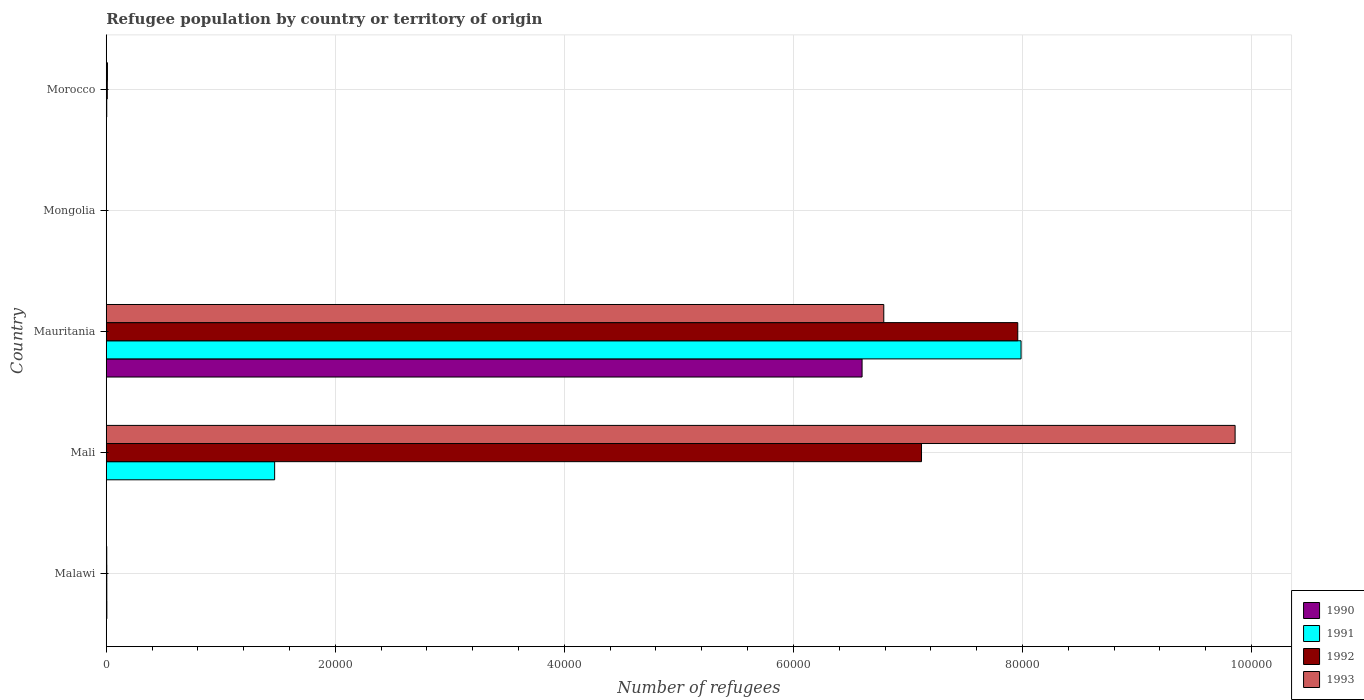How many groups of bars are there?
Offer a terse response. 5. Are the number of bars per tick equal to the number of legend labels?
Provide a short and direct response. Yes. What is the label of the 1st group of bars from the top?
Offer a terse response. Morocco. What is the number of refugees in 1991 in Malawi?
Provide a short and direct response. 50. Across all countries, what is the maximum number of refugees in 1991?
Your answer should be compact. 7.99e+04. In which country was the number of refugees in 1990 maximum?
Provide a succinct answer. Mauritania. In which country was the number of refugees in 1992 minimum?
Ensure brevity in your answer.  Mongolia. What is the total number of refugees in 1992 in the graph?
Offer a very short reply. 1.51e+05. What is the difference between the number of refugees in 1992 in Mauritania and that in Mongolia?
Your answer should be compact. 7.96e+04. What is the difference between the number of refugees in 1993 in Morocco and the number of refugees in 1990 in Mauritania?
Keep it short and to the point. -6.59e+04. What is the average number of refugees in 1992 per country?
Provide a succinct answer. 3.02e+04. What is the difference between the number of refugees in 1990 and number of refugees in 1992 in Malawi?
Provide a succinct answer. 3. What is the ratio of the number of refugees in 1991 in Malawi to that in Mali?
Provide a succinct answer. 0. Is the difference between the number of refugees in 1990 in Mongolia and Morocco greater than the difference between the number of refugees in 1992 in Mongolia and Morocco?
Make the answer very short. Yes. What is the difference between the highest and the second highest number of refugees in 1992?
Ensure brevity in your answer.  8405. What is the difference between the highest and the lowest number of refugees in 1992?
Your answer should be compact. 7.96e+04. Is it the case that in every country, the sum of the number of refugees in 1992 and number of refugees in 1990 is greater than the sum of number of refugees in 1991 and number of refugees in 1993?
Your answer should be very brief. No. What does the 3rd bar from the top in Mauritania represents?
Ensure brevity in your answer.  1991. What does the 3rd bar from the bottom in Morocco represents?
Make the answer very short. 1992. Is it the case that in every country, the sum of the number of refugees in 1990 and number of refugees in 1991 is greater than the number of refugees in 1993?
Offer a terse response. No. Are all the bars in the graph horizontal?
Provide a succinct answer. Yes. Where does the legend appear in the graph?
Offer a very short reply. Bottom right. How many legend labels are there?
Offer a terse response. 4. What is the title of the graph?
Offer a terse response. Refugee population by country or territory of origin. What is the label or title of the X-axis?
Offer a terse response. Number of refugees. What is the Number of refugees of 1990 in Malawi?
Provide a short and direct response. 53. What is the Number of refugees in 1991 in Malawi?
Make the answer very short. 50. What is the Number of refugees in 1992 in Malawi?
Provide a succinct answer. 50. What is the Number of refugees in 1990 in Mali?
Ensure brevity in your answer.  1. What is the Number of refugees in 1991 in Mali?
Offer a terse response. 1.47e+04. What is the Number of refugees in 1992 in Mali?
Provide a succinct answer. 7.12e+04. What is the Number of refugees in 1993 in Mali?
Your response must be concise. 9.86e+04. What is the Number of refugees of 1990 in Mauritania?
Provide a short and direct response. 6.60e+04. What is the Number of refugees in 1991 in Mauritania?
Provide a succinct answer. 7.99e+04. What is the Number of refugees of 1992 in Mauritania?
Provide a short and direct response. 7.96e+04. What is the Number of refugees of 1993 in Mauritania?
Your answer should be compact. 6.79e+04. What is the Number of refugees in 1991 in Mongolia?
Keep it short and to the point. 1. What is the Number of refugees of 1992 in Mongolia?
Offer a very short reply. 1. What is the Number of refugees in 1993 in Mongolia?
Provide a short and direct response. 1. What is the Number of refugees of 1990 in Morocco?
Make the answer very short. 15. What is the Number of refugees in 1991 in Morocco?
Your answer should be compact. 44. What is the Number of refugees of 1992 in Morocco?
Give a very brief answer. 91. What is the Number of refugees in 1993 in Morocco?
Your response must be concise. 105. Across all countries, what is the maximum Number of refugees in 1990?
Offer a very short reply. 6.60e+04. Across all countries, what is the maximum Number of refugees in 1991?
Give a very brief answer. 7.99e+04. Across all countries, what is the maximum Number of refugees in 1992?
Provide a succinct answer. 7.96e+04. Across all countries, what is the maximum Number of refugees of 1993?
Keep it short and to the point. 9.86e+04. Across all countries, what is the minimum Number of refugees of 1991?
Offer a terse response. 1. Across all countries, what is the minimum Number of refugees of 1992?
Give a very brief answer. 1. Across all countries, what is the minimum Number of refugees of 1993?
Provide a short and direct response. 1. What is the total Number of refugees of 1990 in the graph?
Your response must be concise. 6.61e+04. What is the total Number of refugees of 1991 in the graph?
Give a very brief answer. 9.47e+04. What is the total Number of refugees of 1992 in the graph?
Your response must be concise. 1.51e+05. What is the total Number of refugees of 1993 in the graph?
Provide a succinct answer. 1.67e+05. What is the difference between the Number of refugees in 1991 in Malawi and that in Mali?
Provide a succinct answer. -1.47e+04. What is the difference between the Number of refugees in 1992 in Malawi and that in Mali?
Give a very brief answer. -7.11e+04. What is the difference between the Number of refugees of 1993 in Malawi and that in Mali?
Keep it short and to the point. -9.85e+04. What is the difference between the Number of refugees in 1990 in Malawi and that in Mauritania?
Offer a terse response. -6.59e+04. What is the difference between the Number of refugees in 1991 in Malawi and that in Mauritania?
Give a very brief answer. -7.98e+04. What is the difference between the Number of refugees in 1992 in Malawi and that in Mauritania?
Your answer should be very brief. -7.95e+04. What is the difference between the Number of refugees in 1993 in Malawi and that in Mauritania?
Provide a succinct answer. -6.78e+04. What is the difference between the Number of refugees of 1992 in Malawi and that in Mongolia?
Your answer should be compact. 49. What is the difference between the Number of refugees in 1991 in Malawi and that in Morocco?
Ensure brevity in your answer.  6. What is the difference between the Number of refugees of 1992 in Malawi and that in Morocco?
Provide a short and direct response. -41. What is the difference between the Number of refugees in 1993 in Malawi and that in Morocco?
Offer a terse response. -61. What is the difference between the Number of refugees in 1990 in Mali and that in Mauritania?
Ensure brevity in your answer.  -6.60e+04. What is the difference between the Number of refugees of 1991 in Mali and that in Mauritania?
Your answer should be very brief. -6.52e+04. What is the difference between the Number of refugees in 1992 in Mali and that in Mauritania?
Make the answer very short. -8405. What is the difference between the Number of refugees of 1993 in Mali and that in Mauritania?
Provide a short and direct response. 3.07e+04. What is the difference between the Number of refugees in 1990 in Mali and that in Mongolia?
Offer a terse response. 0. What is the difference between the Number of refugees of 1991 in Mali and that in Mongolia?
Offer a very short reply. 1.47e+04. What is the difference between the Number of refugees of 1992 in Mali and that in Mongolia?
Give a very brief answer. 7.12e+04. What is the difference between the Number of refugees in 1993 in Mali and that in Mongolia?
Offer a terse response. 9.86e+04. What is the difference between the Number of refugees of 1990 in Mali and that in Morocco?
Make the answer very short. -14. What is the difference between the Number of refugees in 1991 in Mali and that in Morocco?
Offer a very short reply. 1.47e+04. What is the difference between the Number of refugees in 1992 in Mali and that in Morocco?
Make the answer very short. 7.11e+04. What is the difference between the Number of refugees of 1993 in Mali and that in Morocco?
Ensure brevity in your answer.  9.85e+04. What is the difference between the Number of refugees in 1990 in Mauritania and that in Mongolia?
Provide a succinct answer. 6.60e+04. What is the difference between the Number of refugees of 1991 in Mauritania and that in Mongolia?
Provide a succinct answer. 7.99e+04. What is the difference between the Number of refugees in 1992 in Mauritania and that in Mongolia?
Keep it short and to the point. 7.96e+04. What is the difference between the Number of refugees of 1993 in Mauritania and that in Mongolia?
Provide a short and direct response. 6.79e+04. What is the difference between the Number of refugees in 1990 in Mauritania and that in Morocco?
Make the answer very short. 6.60e+04. What is the difference between the Number of refugees of 1991 in Mauritania and that in Morocco?
Make the answer very short. 7.98e+04. What is the difference between the Number of refugees in 1992 in Mauritania and that in Morocco?
Your answer should be compact. 7.95e+04. What is the difference between the Number of refugees in 1993 in Mauritania and that in Morocco?
Your answer should be very brief. 6.78e+04. What is the difference between the Number of refugees in 1991 in Mongolia and that in Morocco?
Your response must be concise. -43. What is the difference between the Number of refugees in 1992 in Mongolia and that in Morocco?
Provide a succinct answer. -90. What is the difference between the Number of refugees of 1993 in Mongolia and that in Morocco?
Offer a very short reply. -104. What is the difference between the Number of refugees in 1990 in Malawi and the Number of refugees in 1991 in Mali?
Provide a short and direct response. -1.47e+04. What is the difference between the Number of refugees of 1990 in Malawi and the Number of refugees of 1992 in Mali?
Make the answer very short. -7.11e+04. What is the difference between the Number of refugees of 1990 in Malawi and the Number of refugees of 1993 in Mali?
Make the answer very short. -9.85e+04. What is the difference between the Number of refugees of 1991 in Malawi and the Number of refugees of 1992 in Mali?
Make the answer very short. -7.11e+04. What is the difference between the Number of refugees of 1991 in Malawi and the Number of refugees of 1993 in Mali?
Your answer should be very brief. -9.85e+04. What is the difference between the Number of refugees in 1992 in Malawi and the Number of refugees in 1993 in Mali?
Provide a short and direct response. -9.85e+04. What is the difference between the Number of refugees in 1990 in Malawi and the Number of refugees in 1991 in Mauritania?
Provide a succinct answer. -7.98e+04. What is the difference between the Number of refugees of 1990 in Malawi and the Number of refugees of 1992 in Mauritania?
Provide a succinct answer. -7.95e+04. What is the difference between the Number of refugees in 1990 in Malawi and the Number of refugees in 1993 in Mauritania?
Keep it short and to the point. -6.78e+04. What is the difference between the Number of refugees of 1991 in Malawi and the Number of refugees of 1992 in Mauritania?
Provide a succinct answer. -7.95e+04. What is the difference between the Number of refugees of 1991 in Malawi and the Number of refugees of 1993 in Mauritania?
Keep it short and to the point. -6.78e+04. What is the difference between the Number of refugees of 1992 in Malawi and the Number of refugees of 1993 in Mauritania?
Make the answer very short. -6.78e+04. What is the difference between the Number of refugees of 1990 in Malawi and the Number of refugees of 1992 in Mongolia?
Give a very brief answer. 52. What is the difference between the Number of refugees in 1992 in Malawi and the Number of refugees in 1993 in Mongolia?
Provide a succinct answer. 49. What is the difference between the Number of refugees of 1990 in Malawi and the Number of refugees of 1992 in Morocco?
Give a very brief answer. -38. What is the difference between the Number of refugees in 1990 in Malawi and the Number of refugees in 1993 in Morocco?
Give a very brief answer. -52. What is the difference between the Number of refugees of 1991 in Malawi and the Number of refugees of 1992 in Morocco?
Provide a short and direct response. -41. What is the difference between the Number of refugees in 1991 in Malawi and the Number of refugees in 1993 in Morocco?
Your answer should be compact. -55. What is the difference between the Number of refugees of 1992 in Malawi and the Number of refugees of 1993 in Morocco?
Offer a terse response. -55. What is the difference between the Number of refugees in 1990 in Mali and the Number of refugees in 1991 in Mauritania?
Provide a succinct answer. -7.99e+04. What is the difference between the Number of refugees of 1990 in Mali and the Number of refugees of 1992 in Mauritania?
Offer a terse response. -7.96e+04. What is the difference between the Number of refugees in 1990 in Mali and the Number of refugees in 1993 in Mauritania?
Keep it short and to the point. -6.79e+04. What is the difference between the Number of refugees in 1991 in Mali and the Number of refugees in 1992 in Mauritania?
Keep it short and to the point. -6.49e+04. What is the difference between the Number of refugees in 1991 in Mali and the Number of refugees in 1993 in Mauritania?
Offer a terse response. -5.32e+04. What is the difference between the Number of refugees of 1992 in Mali and the Number of refugees of 1993 in Mauritania?
Your response must be concise. 3295. What is the difference between the Number of refugees of 1990 in Mali and the Number of refugees of 1991 in Mongolia?
Give a very brief answer. 0. What is the difference between the Number of refugees in 1990 in Mali and the Number of refugees in 1993 in Mongolia?
Offer a very short reply. 0. What is the difference between the Number of refugees of 1991 in Mali and the Number of refugees of 1992 in Mongolia?
Offer a terse response. 1.47e+04. What is the difference between the Number of refugees in 1991 in Mali and the Number of refugees in 1993 in Mongolia?
Provide a short and direct response. 1.47e+04. What is the difference between the Number of refugees in 1992 in Mali and the Number of refugees in 1993 in Mongolia?
Your answer should be compact. 7.12e+04. What is the difference between the Number of refugees in 1990 in Mali and the Number of refugees in 1991 in Morocco?
Make the answer very short. -43. What is the difference between the Number of refugees in 1990 in Mali and the Number of refugees in 1992 in Morocco?
Provide a short and direct response. -90. What is the difference between the Number of refugees in 1990 in Mali and the Number of refugees in 1993 in Morocco?
Make the answer very short. -104. What is the difference between the Number of refugees in 1991 in Mali and the Number of refugees in 1992 in Morocco?
Keep it short and to the point. 1.46e+04. What is the difference between the Number of refugees of 1991 in Mali and the Number of refugees of 1993 in Morocco?
Keep it short and to the point. 1.46e+04. What is the difference between the Number of refugees in 1992 in Mali and the Number of refugees in 1993 in Morocco?
Offer a terse response. 7.11e+04. What is the difference between the Number of refugees in 1990 in Mauritania and the Number of refugees in 1991 in Mongolia?
Offer a very short reply. 6.60e+04. What is the difference between the Number of refugees of 1990 in Mauritania and the Number of refugees of 1992 in Mongolia?
Offer a terse response. 6.60e+04. What is the difference between the Number of refugees of 1990 in Mauritania and the Number of refugees of 1993 in Mongolia?
Give a very brief answer. 6.60e+04. What is the difference between the Number of refugees of 1991 in Mauritania and the Number of refugees of 1992 in Mongolia?
Make the answer very short. 7.99e+04. What is the difference between the Number of refugees of 1991 in Mauritania and the Number of refugees of 1993 in Mongolia?
Provide a short and direct response. 7.99e+04. What is the difference between the Number of refugees in 1992 in Mauritania and the Number of refugees in 1993 in Mongolia?
Keep it short and to the point. 7.96e+04. What is the difference between the Number of refugees of 1990 in Mauritania and the Number of refugees of 1991 in Morocco?
Your response must be concise. 6.60e+04. What is the difference between the Number of refugees in 1990 in Mauritania and the Number of refugees in 1992 in Morocco?
Provide a succinct answer. 6.59e+04. What is the difference between the Number of refugees in 1990 in Mauritania and the Number of refugees in 1993 in Morocco?
Your response must be concise. 6.59e+04. What is the difference between the Number of refugees in 1991 in Mauritania and the Number of refugees in 1992 in Morocco?
Provide a short and direct response. 7.98e+04. What is the difference between the Number of refugees of 1991 in Mauritania and the Number of refugees of 1993 in Morocco?
Keep it short and to the point. 7.98e+04. What is the difference between the Number of refugees of 1992 in Mauritania and the Number of refugees of 1993 in Morocco?
Provide a succinct answer. 7.95e+04. What is the difference between the Number of refugees in 1990 in Mongolia and the Number of refugees in 1991 in Morocco?
Keep it short and to the point. -43. What is the difference between the Number of refugees of 1990 in Mongolia and the Number of refugees of 1992 in Morocco?
Offer a terse response. -90. What is the difference between the Number of refugees in 1990 in Mongolia and the Number of refugees in 1993 in Morocco?
Your answer should be compact. -104. What is the difference between the Number of refugees in 1991 in Mongolia and the Number of refugees in 1992 in Morocco?
Give a very brief answer. -90. What is the difference between the Number of refugees in 1991 in Mongolia and the Number of refugees in 1993 in Morocco?
Make the answer very short. -104. What is the difference between the Number of refugees in 1992 in Mongolia and the Number of refugees in 1993 in Morocco?
Offer a terse response. -104. What is the average Number of refugees in 1990 per country?
Offer a very short reply. 1.32e+04. What is the average Number of refugees in 1991 per country?
Provide a succinct answer. 1.89e+04. What is the average Number of refugees in 1992 per country?
Keep it short and to the point. 3.02e+04. What is the average Number of refugees in 1993 per country?
Keep it short and to the point. 3.33e+04. What is the difference between the Number of refugees in 1990 and Number of refugees in 1992 in Malawi?
Offer a very short reply. 3. What is the difference between the Number of refugees of 1990 and Number of refugees of 1993 in Malawi?
Give a very brief answer. 9. What is the difference between the Number of refugees of 1991 and Number of refugees of 1993 in Malawi?
Your answer should be compact. 6. What is the difference between the Number of refugees of 1990 and Number of refugees of 1991 in Mali?
Your response must be concise. -1.47e+04. What is the difference between the Number of refugees of 1990 and Number of refugees of 1992 in Mali?
Provide a succinct answer. -7.12e+04. What is the difference between the Number of refugees in 1990 and Number of refugees in 1993 in Mali?
Keep it short and to the point. -9.86e+04. What is the difference between the Number of refugees of 1991 and Number of refugees of 1992 in Mali?
Give a very brief answer. -5.65e+04. What is the difference between the Number of refugees in 1991 and Number of refugees in 1993 in Mali?
Provide a succinct answer. -8.39e+04. What is the difference between the Number of refugees in 1992 and Number of refugees in 1993 in Mali?
Your answer should be compact. -2.74e+04. What is the difference between the Number of refugees in 1990 and Number of refugees in 1991 in Mauritania?
Ensure brevity in your answer.  -1.39e+04. What is the difference between the Number of refugees in 1990 and Number of refugees in 1992 in Mauritania?
Ensure brevity in your answer.  -1.36e+04. What is the difference between the Number of refugees in 1990 and Number of refugees in 1993 in Mauritania?
Provide a short and direct response. -1895. What is the difference between the Number of refugees in 1991 and Number of refugees in 1992 in Mauritania?
Your answer should be compact. 287. What is the difference between the Number of refugees of 1991 and Number of refugees of 1993 in Mauritania?
Offer a terse response. 1.20e+04. What is the difference between the Number of refugees in 1992 and Number of refugees in 1993 in Mauritania?
Offer a terse response. 1.17e+04. What is the difference between the Number of refugees of 1990 and Number of refugees of 1991 in Morocco?
Your answer should be compact. -29. What is the difference between the Number of refugees in 1990 and Number of refugees in 1992 in Morocco?
Offer a very short reply. -76. What is the difference between the Number of refugees of 1990 and Number of refugees of 1993 in Morocco?
Your answer should be very brief. -90. What is the difference between the Number of refugees in 1991 and Number of refugees in 1992 in Morocco?
Offer a terse response. -47. What is the difference between the Number of refugees in 1991 and Number of refugees in 1993 in Morocco?
Ensure brevity in your answer.  -61. What is the ratio of the Number of refugees of 1990 in Malawi to that in Mali?
Offer a very short reply. 53. What is the ratio of the Number of refugees in 1991 in Malawi to that in Mali?
Provide a short and direct response. 0. What is the ratio of the Number of refugees in 1992 in Malawi to that in Mali?
Provide a short and direct response. 0. What is the ratio of the Number of refugees of 1990 in Malawi to that in Mauritania?
Ensure brevity in your answer.  0. What is the ratio of the Number of refugees of 1991 in Malawi to that in Mauritania?
Give a very brief answer. 0. What is the ratio of the Number of refugees in 1992 in Malawi to that in Mauritania?
Ensure brevity in your answer.  0. What is the ratio of the Number of refugees in 1993 in Malawi to that in Mauritania?
Offer a terse response. 0. What is the ratio of the Number of refugees of 1991 in Malawi to that in Mongolia?
Your response must be concise. 50. What is the ratio of the Number of refugees in 1992 in Malawi to that in Mongolia?
Ensure brevity in your answer.  50. What is the ratio of the Number of refugees in 1993 in Malawi to that in Mongolia?
Your response must be concise. 44. What is the ratio of the Number of refugees of 1990 in Malawi to that in Morocco?
Offer a terse response. 3.53. What is the ratio of the Number of refugees in 1991 in Malawi to that in Morocco?
Offer a terse response. 1.14. What is the ratio of the Number of refugees in 1992 in Malawi to that in Morocco?
Give a very brief answer. 0.55. What is the ratio of the Number of refugees in 1993 in Malawi to that in Morocco?
Your answer should be very brief. 0.42. What is the ratio of the Number of refugees of 1990 in Mali to that in Mauritania?
Ensure brevity in your answer.  0. What is the ratio of the Number of refugees in 1991 in Mali to that in Mauritania?
Ensure brevity in your answer.  0.18. What is the ratio of the Number of refugees of 1992 in Mali to that in Mauritania?
Your answer should be very brief. 0.89. What is the ratio of the Number of refugees in 1993 in Mali to that in Mauritania?
Keep it short and to the point. 1.45. What is the ratio of the Number of refugees of 1990 in Mali to that in Mongolia?
Your answer should be compact. 1. What is the ratio of the Number of refugees of 1991 in Mali to that in Mongolia?
Your answer should be very brief. 1.47e+04. What is the ratio of the Number of refugees of 1992 in Mali to that in Mongolia?
Your answer should be compact. 7.12e+04. What is the ratio of the Number of refugees of 1993 in Mali to that in Mongolia?
Make the answer very short. 9.86e+04. What is the ratio of the Number of refugees in 1990 in Mali to that in Morocco?
Your response must be concise. 0.07. What is the ratio of the Number of refugees of 1991 in Mali to that in Morocco?
Your response must be concise. 334.18. What is the ratio of the Number of refugees of 1992 in Mali to that in Morocco?
Make the answer very short. 782.3. What is the ratio of the Number of refugees in 1993 in Mali to that in Morocco?
Your answer should be very brief. 938.78. What is the ratio of the Number of refugees in 1990 in Mauritania to that in Mongolia?
Offer a very short reply. 6.60e+04. What is the ratio of the Number of refugees of 1991 in Mauritania to that in Mongolia?
Keep it short and to the point. 7.99e+04. What is the ratio of the Number of refugees of 1992 in Mauritania to that in Mongolia?
Your answer should be very brief. 7.96e+04. What is the ratio of the Number of refugees in 1993 in Mauritania to that in Mongolia?
Keep it short and to the point. 6.79e+04. What is the ratio of the Number of refugees in 1990 in Mauritania to that in Morocco?
Your answer should be compact. 4399.93. What is the ratio of the Number of refugees in 1991 in Mauritania to that in Morocco?
Your answer should be very brief. 1815.48. What is the ratio of the Number of refugees in 1992 in Mauritania to that in Morocco?
Offer a terse response. 874.66. What is the ratio of the Number of refugees in 1993 in Mauritania to that in Morocco?
Your response must be concise. 646.61. What is the ratio of the Number of refugees in 1990 in Mongolia to that in Morocco?
Your answer should be very brief. 0.07. What is the ratio of the Number of refugees of 1991 in Mongolia to that in Morocco?
Your answer should be very brief. 0.02. What is the ratio of the Number of refugees in 1992 in Mongolia to that in Morocco?
Keep it short and to the point. 0.01. What is the ratio of the Number of refugees of 1993 in Mongolia to that in Morocco?
Give a very brief answer. 0.01. What is the difference between the highest and the second highest Number of refugees of 1990?
Your answer should be compact. 6.59e+04. What is the difference between the highest and the second highest Number of refugees of 1991?
Your answer should be compact. 6.52e+04. What is the difference between the highest and the second highest Number of refugees in 1992?
Keep it short and to the point. 8405. What is the difference between the highest and the second highest Number of refugees in 1993?
Offer a very short reply. 3.07e+04. What is the difference between the highest and the lowest Number of refugees in 1990?
Your response must be concise. 6.60e+04. What is the difference between the highest and the lowest Number of refugees in 1991?
Your response must be concise. 7.99e+04. What is the difference between the highest and the lowest Number of refugees of 1992?
Offer a terse response. 7.96e+04. What is the difference between the highest and the lowest Number of refugees of 1993?
Your response must be concise. 9.86e+04. 